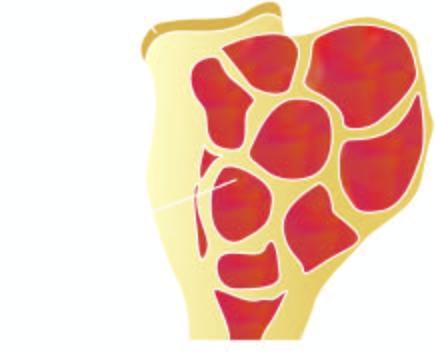s the end of the long bone expanded in the region of epiphysis?
Answer the question using a single word or phrase. Yes 